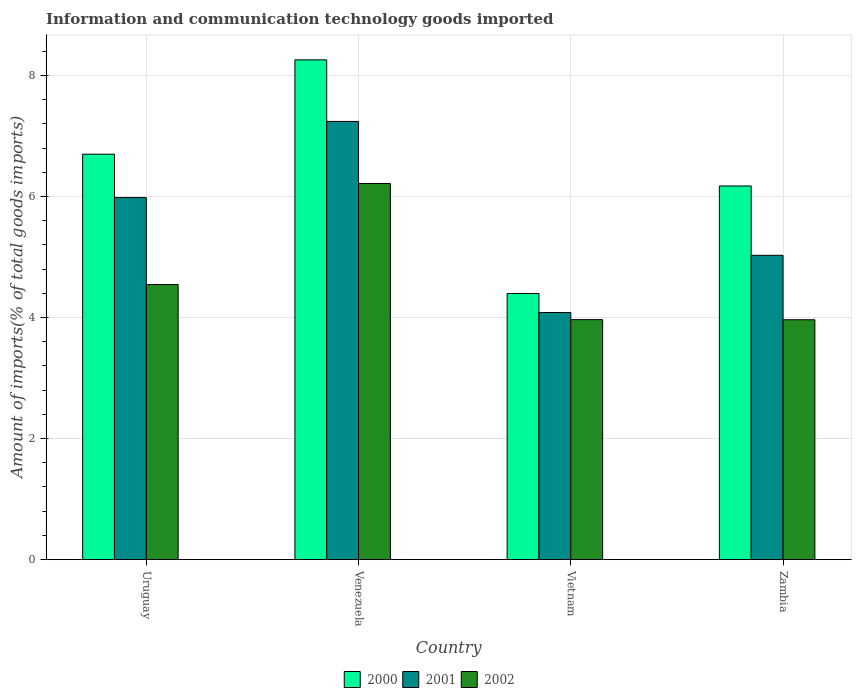Are the number of bars per tick equal to the number of legend labels?
Your answer should be compact. Yes. How many bars are there on the 1st tick from the left?
Provide a succinct answer. 3. How many bars are there on the 4th tick from the right?
Your answer should be very brief. 3. What is the label of the 3rd group of bars from the left?
Ensure brevity in your answer.  Vietnam. What is the amount of goods imported in 2002 in Zambia?
Give a very brief answer. 3.96. Across all countries, what is the maximum amount of goods imported in 2002?
Provide a succinct answer. 6.22. Across all countries, what is the minimum amount of goods imported in 2001?
Offer a terse response. 4.08. In which country was the amount of goods imported in 2002 maximum?
Your answer should be compact. Venezuela. In which country was the amount of goods imported in 2002 minimum?
Your answer should be compact. Zambia. What is the total amount of goods imported in 2002 in the graph?
Keep it short and to the point. 18.69. What is the difference between the amount of goods imported in 2001 in Venezuela and that in Vietnam?
Make the answer very short. 3.16. What is the difference between the amount of goods imported in 2002 in Venezuela and the amount of goods imported in 2000 in Uruguay?
Keep it short and to the point. -0.48. What is the average amount of goods imported in 2001 per country?
Your answer should be very brief. 5.58. What is the difference between the amount of goods imported of/in 2000 and amount of goods imported of/in 2001 in Zambia?
Give a very brief answer. 1.15. In how many countries, is the amount of goods imported in 2000 greater than 8 %?
Give a very brief answer. 1. What is the ratio of the amount of goods imported in 2002 in Uruguay to that in Vietnam?
Your answer should be very brief. 1.15. Is the difference between the amount of goods imported in 2000 in Venezuela and Vietnam greater than the difference between the amount of goods imported in 2001 in Venezuela and Vietnam?
Provide a succinct answer. Yes. What is the difference between the highest and the second highest amount of goods imported in 2000?
Your answer should be compact. 1.56. What is the difference between the highest and the lowest amount of goods imported in 2000?
Provide a succinct answer. 3.86. In how many countries, is the amount of goods imported in 2002 greater than the average amount of goods imported in 2002 taken over all countries?
Give a very brief answer. 1. What does the 2nd bar from the left in Uruguay represents?
Provide a succinct answer. 2001. How many bars are there?
Make the answer very short. 12. Are all the bars in the graph horizontal?
Provide a succinct answer. No. How many countries are there in the graph?
Make the answer very short. 4. How many legend labels are there?
Keep it short and to the point. 3. How are the legend labels stacked?
Offer a very short reply. Horizontal. What is the title of the graph?
Give a very brief answer. Information and communication technology goods imported. What is the label or title of the X-axis?
Keep it short and to the point. Country. What is the label or title of the Y-axis?
Provide a short and direct response. Amount of imports(% of total goods imports). What is the Amount of imports(% of total goods imports) in 2000 in Uruguay?
Offer a very short reply. 6.7. What is the Amount of imports(% of total goods imports) of 2001 in Uruguay?
Ensure brevity in your answer.  5.98. What is the Amount of imports(% of total goods imports) in 2002 in Uruguay?
Keep it short and to the point. 4.55. What is the Amount of imports(% of total goods imports) of 2000 in Venezuela?
Keep it short and to the point. 8.26. What is the Amount of imports(% of total goods imports) in 2001 in Venezuela?
Offer a terse response. 7.24. What is the Amount of imports(% of total goods imports) of 2002 in Venezuela?
Offer a very short reply. 6.22. What is the Amount of imports(% of total goods imports) of 2000 in Vietnam?
Ensure brevity in your answer.  4.4. What is the Amount of imports(% of total goods imports) of 2001 in Vietnam?
Keep it short and to the point. 4.08. What is the Amount of imports(% of total goods imports) in 2002 in Vietnam?
Give a very brief answer. 3.97. What is the Amount of imports(% of total goods imports) of 2000 in Zambia?
Offer a very short reply. 6.17. What is the Amount of imports(% of total goods imports) of 2001 in Zambia?
Ensure brevity in your answer.  5.03. What is the Amount of imports(% of total goods imports) of 2002 in Zambia?
Ensure brevity in your answer.  3.96. Across all countries, what is the maximum Amount of imports(% of total goods imports) in 2000?
Your answer should be very brief. 8.26. Across all countries, what is the maximum Amount of imports(% of total goods imports) in 2001?
Provide a short and direct response. 7.24. Across all countries, what is the maximum Amount of imports(% of total goods imports) in 2002?
Make the answer very short. 6.22. Across all countries, what is the minimum Amount of imports(% of total goods imports) in 2000?
Provide a short and direct response. 4.4. Across all countries, what is the minimum Amount of imports(% of total goods imports) of 2001?
Your answer should be compact. 4.08. Across all countries, what is the minimum Amount of imports(% of total goods imports) in 2002?
Ensure brevity in your answer.  3.96. What is the total Amount of imports(% of total goods imports) in 2000 in the graph?
Keep it short and to the point. 25.53. What is the total Amount of imports(% of total goods imports) of 2001 in the graph?
Provide a short and direct response. 22.33. What is the total Amount of imports(% of total goods imports) in 2002 in the graph?
Your answer should be compact. 18.69. What is the difference between the Amount of imports(% of total goods imports) of 2000 in Uruguay and that in Venezuela?
Provide a short and direct response. -1.56. What is the difference between the Amount of imports(% of total goods imports) in 2001 in Uruguay and that in Venezuela?
Ensure brevity in your answer.  -1.26. What is the difference between the Amount of imports(% of total goods imports) of 2002 in Uruguay and that in Venezuela?
Offer a very short reply. -1.67. What is the difference between the Amount of imports(% of total goods imports) in 2000 in Uruguay and that in Vietnam?
Offer a very short reply. 2.3. What is the difference between the Amount of imports(% of total goods imports) in 2001 in Uruguay and that in Vietnam?
Offer a terse response. 1.9. What is the difference between the Amount of imports(% of total goods imports) in 2002 in Uruguay and that in Vietnam?
Make the answer very short. 0.58. What is the difference between the Amount of imports(% of total goods imports) of 2000 in Uruguay and that in Zambia?
Give a very brief answer. 0.53. What is the difference between the Amount of imports(% of total goods imports) in 2001 in Uruguay and that in Zambia?
Your answer should be compact. 0.95. What is the difference between the Amount of imports(% of total goods imports) of 2002 in Uruguay and that in Zambia?
Your answer should be very brief. 0.58. What is the difference between the Amount of imports(% of total goods imports) in 2000 in Venezuela and that in Vietnam?
Keep it short and to the point. 3.86. What is the difference between the Amount of imports(% of total goods imports) of 2001 in Venezuela and that in Vietnam?
Offer a terse response. 3.16. What is the difference between the Amount of imports(% of total goods imports) of 2002 in Venezuela and that in Vietnam?
Give a very brief answer. 2.25. What is the difference between the Amount of imports(% of total goods imports) of 2000 in Venezuela and that in Zambia?
Offer a terse response. 2.08. What is the difference between the Amount of imports(% of total goods imports) in 2001 in Venezuela and that in Zambia?
Your response must be concise. 2.21. What is the difference between the Amount of imports(% of total goods imports) in 2002 in Venezuela and that in Zambia?
Your answer should be compact. 2.25. What is the difference between the Amount of imports(% of total goods imports) of 2000 in Vietnam and that in Zambia?
Your response must be concise. -1.78. What is the difference between the Amount of imports(% of total goods imports) of 2001 in Vietnam and that in Zambia?
Provide a succinct answer. -0.95. What is the difference between the Amount of imports(% of total goods imports) in 2002 in Vietnam and that in Zambia?
Your answer should be very brief. 0. What is the difference between the Amount of imports(% of total goods imports) in 2000 in Uruguay and the Amount of imports(% of total goods imports) in 2001 in Venezuela?
Your response must be concise. -0.54. What is the difference between the Amount of imports(% of total goods imports) of 2000 in Uruguay and the Amount of imports(% of total goods imports) of 2002 in Venezuela?
Give a very brief answer. 0.48. What is the difference between the Amount of imports(% of total goods imports) of 2001 in Uruguay and the Amount of imports(% of total goods imports) of 2002 in Venezuela?
Offer a very short reply. -0.23. What is the difference between the Amount of imports(% of total goods imports) of 2000 in Uruguay and the Amount of imports(% of total goods imports) of 2001 in Vietnam?
Provide a short and direct response. 2.62. What is the difference between the Amount of imports(% of total goods imports) in 2000 in Uruguay and the Amount of imports(% of total goods imports) in 2002 in Vietnam?
Offer a terse response. 2.73. What is the difference between the Amount of imports(% of total goods imports) of 2001 in Uruguay and the Amount of imports(% of total goods imports) of 2002 in Vietnam?
Offer a terse response. 2.02. What is the difference between the Amount of imports(% of total goods imports) of 2000 in Uruguay and the Amount of imports(% of total goods imports) of 2001 in Zambia?
Offer a terse response. 1.67. What is the difference between the Amount of imports(% of total goods imports) of 2000 in Uruguay and the Amount of imports(% of total goods imports) of 2002 in Zambia?
Your answer should be very brief. 2.74. What is the difference between the Amount of imports(% of total goods imports) in 2001 in Uruguay and the Amount of imports(% of total goods imports) in 2002 in Zambia?
Provide a short and direct response. 2.02. What is the difference between the Amount of imports(% of total goods imports) of 2000 in Venezuela and the Amount of imports(% of total goods imports) of 2001 in Vietnam?
Provide a succinct answer. 4.18. What is the difference between the Amount of imports(% of total goods imports) of 2000 in Venezuela and the Amount of imports(% of total goods imports) of 2002 in Vietnam?
Offer a very short reply. 4.29. What is the difference between the Amount of imports(% of total goods imports) in 2001 in Venezuela and the Amount of imports(% of total goods imports) in 2002 in Vietnam?
Provide a short and direct response. 3.28. What is the difference between the Amount of imports(% of total goods imports) in 2000 in Venezuela and the Amount of imports(% of total goods imports) in 2001 in Zambia?
Ensure brevity in your answer.  3.23. What is the difference between the Amount of imports(% of total goods imports) in 2000 in Venezuela and the Amount of imports(% of total goods imports) in 2002 in Zambia?
Offer a very short reply. 4.29. What is the difference between the Amount of imports(% of total goods imports) in 2001 in Venezuela and the Amount of imports(% of total goods imports) in 2002 in Zambia?
Provide a succinct answer. 3.28. What is the difference between the Amount of imports(% of total goods imports) of 2000 in Vietnam and the Amount of imports(% of total goods imports) of 2001 in Zambia?
Ensure brevity in your answer.  -0.63. What is the difference between the Amount of imports(% of total goods imports) in 2000 in Vietnam and the Amount of imports(% of total goods imports) in 2002 in Zambia?
Ensure brevity in your answer.  0.43. What is the difference between the Amount of imports(% of total goods imports) of 2001 in Vietnam and the Amount of imports(% of total goods imports) of 2002 in Zambia?
Provide a succinct answer. 0.12. What is the average Amount of imports(% of total goods imports) in 2000 per country?
Provide a short and direct response. 6.38. What is the average Amount of imports(% of total goods imports) in 2001 per country?
Provide a short and direct response. 5.58. What is the average Amount of imports(% of total goods imports) of 2002 per country?
Offer a terse response. 4.67. What is the difference between the Amount of imports(% of total goods imports) of 2000 and Amount of imports(% of total goods imports) of 2001 in Uruguay?
Give a very brief answer. 0.72. What is the difference between the Amount of imports(% of total goods imports) in 2000 and Amount of imports(% of total goods imports) in 2002 in Uruguay?
Provide a short and direct response. 2.15. What is the difference between the Amount of imports(% of total goods imports) of 2001 and Amount of imports(% of total goods imports) of 2002 in Uruguay?
Provide a succinct answer. 1.44. What is the difference between the Amount of imports(% of total goods imports) in 2000 and Amount of imports(% of total goods imports) in 2001 in Venezuela?
Provide a succinct answer. 1.02. What is the difference between the Amount of imports(% of total goods imports) of 2000 and Amount of imports(% of total goods imports) of 2002 in Venezuela?
Provide a succinct answer. 2.04. What is the difference between the Amount of imports(% of total goods imports) in 2001 and Amount of imports(% of total goods imports) in 2002 in Venezuela?
Offer a terse response. 1.03. What is the difference between the Amount of imports(% of total goods imports) of 2000 and Amount of imports(% of total goods imports) of 2001 in Vietnam?
Your response must be concise. 0.31. What is the difference between the Amount of imports(% of total goods imports) in 2000 and Amount of imports(% of total goods imports) in 2002 in Vietnam?
Your answer should be very brief. 0.43. What is the difference between the Amount of imports(% of total goods imports) of 2001 and Amount of imports(% of total goods imports) of 2002 in Vietnam?
Provide a short and direct response. 0.12. What is the difference between the Amount of imports(% of total goods imports) in 2000 and Amount of imports(% of total goods imports) in 2001 in Zambia?
Give a very brief answer. 1.15. What is the difference between the Amount of imports(% of total goods imports) in 2000 and Amount of imports(% of total goods imports) in 2002 in Zambia?
Offer a terse response. 2.21. What is the difference between the Amount of imports(% of total goods imports) in 2001 and Amount of imports(% of total goods imports) in 2002 in Zambia?
Provide a succinct answer. 1.06. What is the ratio of the Amount of imports(% of total goods imports) in 2000 in Uruguay to that in Venezuela?
Provide a short and direct response. 0.81. What is the ratio of the Amount of imports(% of total goods imports) of 2001 in Uruguay to that in Venezuela?
Offer a very short reply. 0.83. What is the ratio of the Amount of imports(% of total goods imports) of 2002 in Uruguay to that in Venezuela?
Provide a succinct answer. 0.73. What is the ratio of the Amount of imports(% of total goods imports) of 2000 in Uruguay to that in Vietnam?
Provide a succinct answer. 1.52. What is the ratio of the Amount of imports(% of total goods imports) in 2001 in Uruguay to that in Vietnam?
Your answer should be compact. 1.47. What is the ratio of the Amount of imports(% of total goods imports) of 2002 in Uruguay to that in Vietnam?
Provide a succinct answer. 1.15. What is the ratio of the Amount of imports(% of total goods imports) of 2000 in Uruguay to that in Zambia?
Your answer should be compact. 1.09. What is the ratio of the Amount of imports(% of total goods imports) of 2001 in Uruguay to that in Zambia?
Your answer should be very brief. 1.19. What is the ratio of the Amount of imports(% of total goods imports) of 2002 in Uruguay to that in Zambia?
Keep it short and to the point. 1.15. What is the ratio of the Amount of imports(% of total goods imports) in 2000 in Venezuela to that in Vietnam?
Make the answer very short. 1.88. What is the ratio of the Amount of imports(% of total goods imports) in 2001 in Venezuela to that in Vietnam?
Your answer should be compact. 1.77. What is the ratio of the Amount of imports(% of total goods imports) in 2002 in Venezuela to that in Vietnam?
Provide a short and direct response. 1.57. What is the ratio of the Amount of imports(% of total goods imports) in 2000 in Venezuela to that in Zambia?
Offer a terse response. 1.34. What is the ratio of the Amount of imports(% of total goods imports) of 2001 in Venezuela to that in Zambia?
Ensure brevity in your answer.  1.44. What is the ratio of the Amount of imports(% of total goods imports) in 2002 in Venezuela to that in Zambia?
Offer a very short reply. 1.57. What is the ratio of the Amount of imports(% of total goods imports) in 2000 in Vietnam to that in Zambia?
Give a very brief answer. 0.71. What is the ratio of the Amount of imports(% of total goods imports) of 2001 in Vietnam to that in Zambia?
Provide a succinct answer. 0.81. What is the difference between the highest and the second highest Amount of imports(% of total goods imports) in 2000?
Your answer should be compact. 1.56. What is the difference between the highest and the second highest Amount of imports(% of total goods imports) in 2001?
Keep it short and to the point. 1.26. What is the difference between the highest and the second highest Amount of imports(% of total goods imports) of 2002?
Give a very brief answer. 1.67. What is the difference between the highest and the lowest Amount of imports(% of total goods imports) in 2000?
Offer a very short reply. 3.86. What is the difference between the highest and the lowest Amount of imports(% of total goods imports) in 2001?
Make the answer very short. 3.16. What is the difference between the highest and the lowest Amount of imports(% of total goods imports) in 2002?
Give a very brief answer. 2.25. 